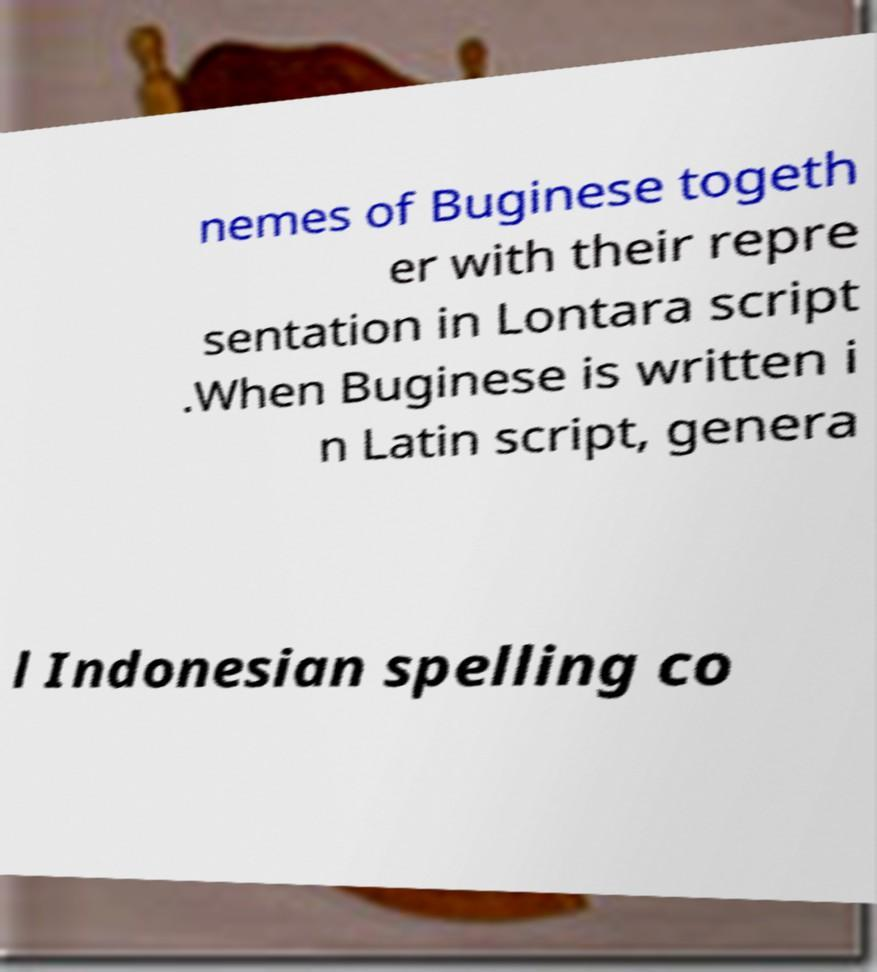There's text embedded in this image that I need extracted. Can you transcribe it verbatim? nemes of Buginese togeth er with their repre sentation in Lontara script .When Buginese is written i n Latin script, genera l Indonesian spelling co 